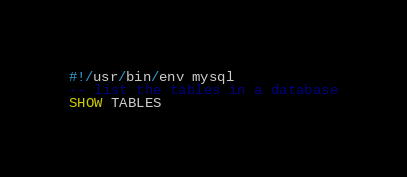Convert code to text. <code><loc_0><loc_0><loc_500><loc_500><_SQL_>#!/usr/bin/env mysql
-- list the tables in a database
SHOW TABLES

</code> 